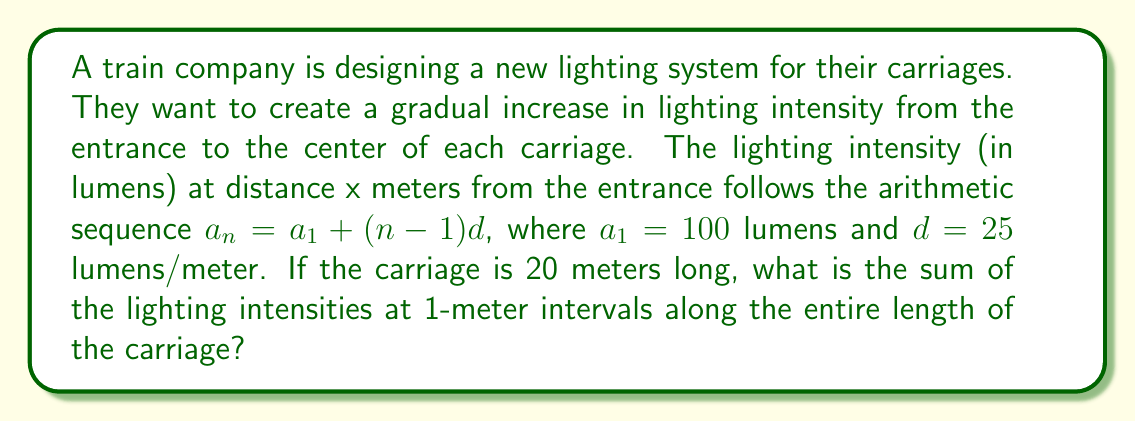Could you help me with this problem? Let's approach this step-by-step:

1) We're dealing with an arithmetic sequence where:
   $a_1 = 100$ (first term)
   $d = 25$ (common difference)
   $n = 20$ (number of terms, as the carriage is 20 meters long)

2) We need to find the sum of this arithmetic sequence. The formula for the sum of an arithmetic sequence is:

   $$S_n = \frac{n}{2}(a_1 + a_n)$$

   where $a_n$ is the last term.

3) To find $a_n$, we use the arithmetic sequence formula:
   $a_n = a_1 + (n-1)d$
   $a_{20} = 100 + (20-1)25 = 100 + 475 = 575$

4) Now we can plug these values into our sum formula:

   $$S_{20} = \frac{20}{2}(100 + 575)$$

5) Simplify:
   $$S_{20} = 10(675) = 6750$$

Therefore, the sum of the lighting intensities along the entire length of the carriage is 6750 lumens.
Answer: 6750 lumens 